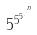<formula> <loc_0><loc_0><loc_500><loc_500>5 ^ { 5 ^ { 5 ^ { . ^ { . ^ { n } } } } }</formula> 